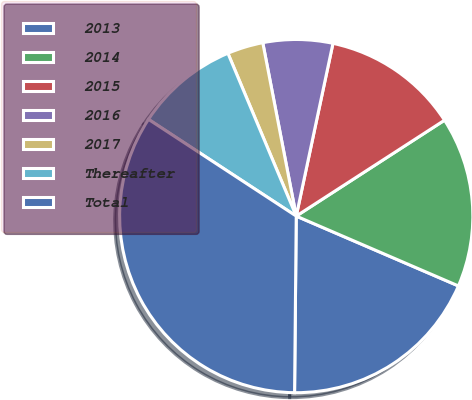<chart> <loc_0><loc_0><loc_500><loc_500><pie_chart><fcel>2013<fcel>2014<fcel>2015<fcel>2016<fcel>2017<fcel>Thereafter<fcel>Total<nl><fcel>18.68%<fcel>15.61%<fcel>12.53%<fcel>6.37%<fcel>3.29%<fcel>9.45%<fcel>34.08%<nl></chart> 